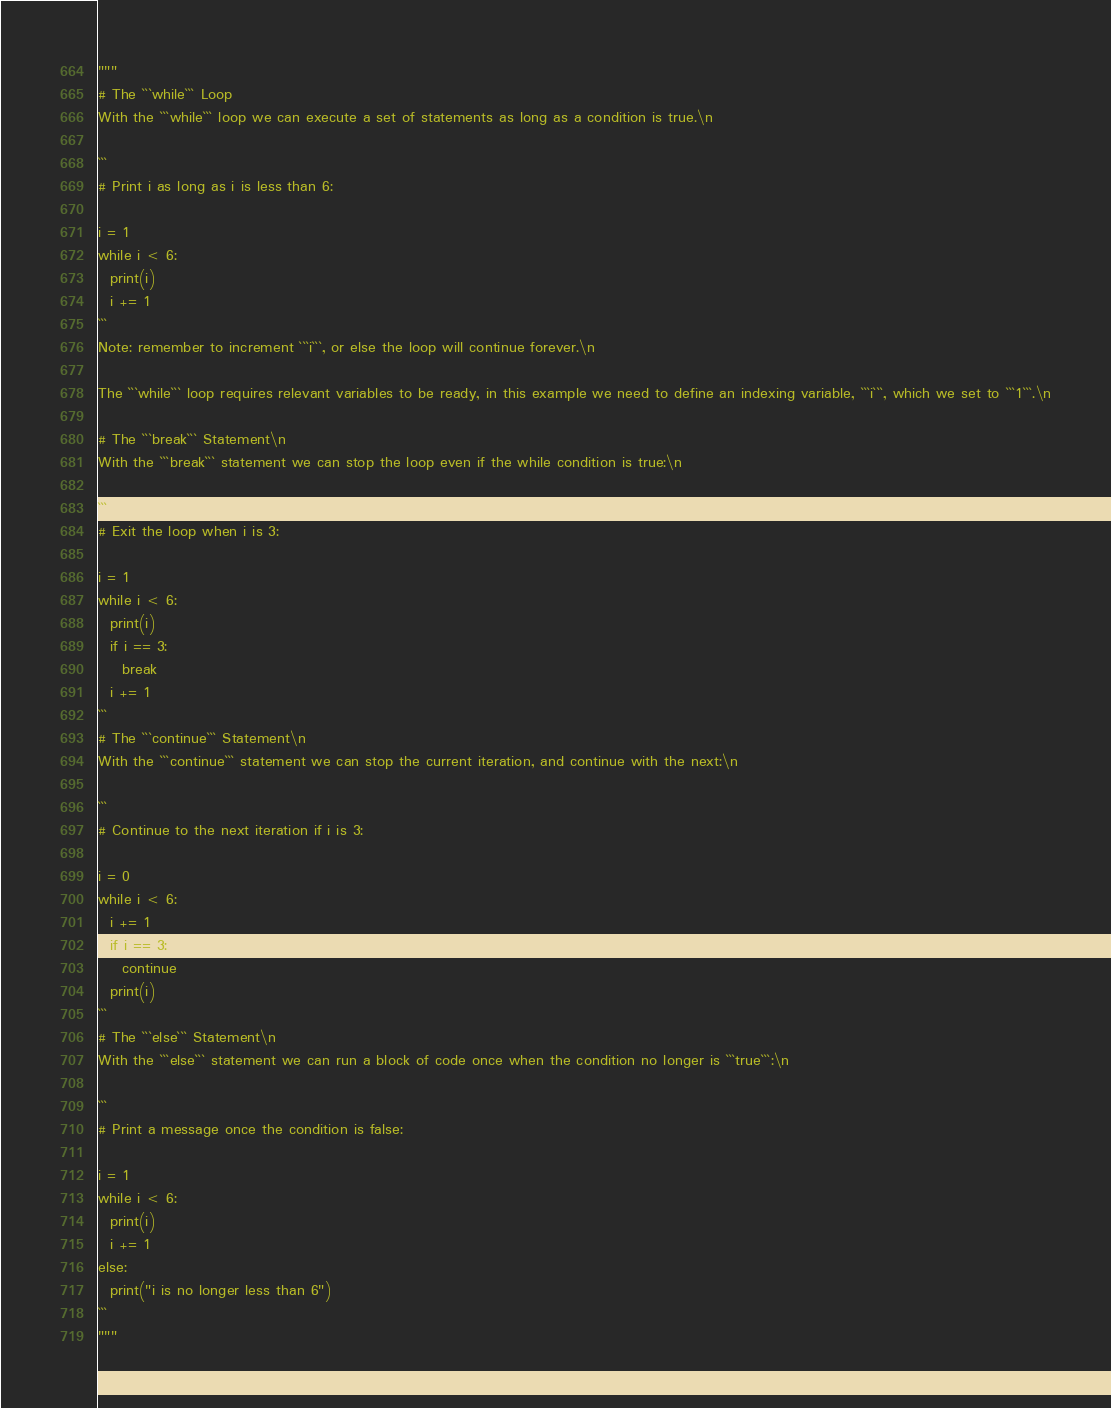Convert code to text. <code><loc_0><loc_0><loc_500><loc_500><_Python_>"""
# The ```while``` Loop
With the ```while``` loop we can execute a set of statements as long as a condition is true.\n

```
# Print i as long as i is less than 6:

i = 1
while i < 6:
  print(i)
  i += 1
```
Note: remember to increment ```i```, or else the loop will continue forever.\n

The ```while``` loop requires relevant variables to be ready, in this example we need to define an indexing variable, ```i```, which we set to ```1```.\n

# The ```break``` Statement\n
With the ```break``` statement we can stop the loop even if the while condition is true:\n

```
# Exit the loop when i is 3:

i = 1
while i < 6:
  print(i)
  if i == 3:
    break
  i += 1
```
# The ```continue``` Statement\n
With the ```continue``` statement we can stop the current iteration, and continue with the next:\n

```
# Continue to the next iteration if i is 3:

i = 0
while i < 6:
  i += 1
  if i == 3:
    continue
  print(i)
```
# The ```else``` Statement\n
With the ```else``` statement we can run a block of code once when the condition no longer is ```true```:\n

```
# Print a message once the condition is false:

i = 1
while i < 6:
  print(i)
  i += 1
else:
  print("i is no longer less than 6")
```
"""</code> 